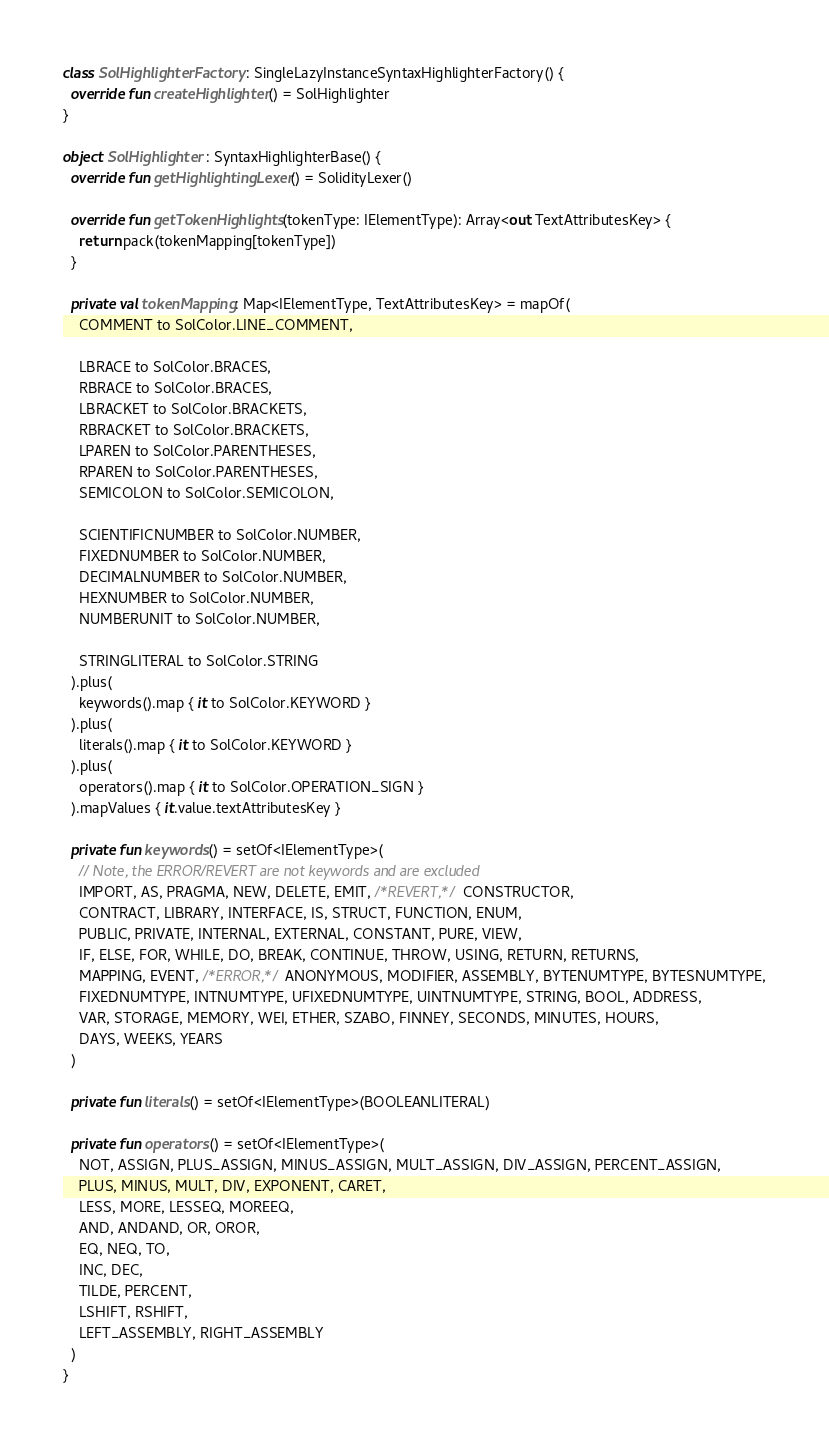Convert code to text. <code><loc_0><loc_0><loc_500><loc_500><_Kotlin_>
class SolHighlighterFactory : SingleLazyInstanceSyntaxHighlighterFactory() {
  override fun createHighlighter() = SolHighlighter
}

object SolHighlighter : SyntaxHighlighterBase() {
  override fun getHighlightingLexer() = SolidityLexer()

  override fun getTokenHighlights(tokenType: IElementType): Array<out TextAttributesKey> {
    return pack(tokenMapping[tokenType])
  }

  private val tokenMapping: Map<IElementType, TextAttributesKey> = mapOf(
    COMMENT to SolColor.LINE_COMMENT,

    LBRACE to SolColor.BRACES,
    RBRACE to SolColor.BRACES,
    LBRACKET to SolColor.BRACKETS,
    RBRACKET to SolColor.BRACKETS,
    LPAREN to SolColor.PARENTHESES,
    RPAREN to SolColor.PARENTHESES,
    SEMICOLON to SolColor.SEMICOLON,

    SCIENTIFICNUMBER to SolColor.NUMBER,
    FIXEDNUMBER to SolColor.NUMBER,
    DECIMALNUMBER to SolColor.NUMBER,
    HEXNUMBER to SolColor.NUMBER,
    NUMBERUNIT to SolColor.NUMBER,

    STRINGLITERAL to SolColor.STRING
  ).plus(
    keywords().map { it to SolColor.KEYWORD }
  ).plus(
    literals().map { it to SolColor.KEYWORD }
  ).plus(
    operators().map { it to SolColor.OPERATION_SIGN }
  ).mapValues { it.value.textAttributesKey }

  private fun keywords() = setOf<IElementType>(
    // Note, the ERROR/REVERT are not keywords and are excluded
    IMPORT, AS, PRAGMA, NEW, DELETE, EMIT, /*REVERT,*/ CONSTRUCTOR,
    CONTRACT, LIBRARY, INTERFACE, IS, STRUCT, FUNCTION, ENUM,
    PUBLIC, PRIVATE, INTERNAL, EXTERNAL, CONSTANT, PURE, VIEW,
    IF, ELSE, FOR, WHILE, DO, BREAK, CONTINUE, THROW, USING, RETURN, RETURNS,
    MAPPING, EVENT, /*ERROR,*/ ANONYMOUS, MODIFIER, ASSEMBLY, BYTENUMTYPE, BYTESNUMTYPE,
    FIXEDNUMTYPE, INTNUMTYPE, UFIXEDNUMTYPE, UINTNUMTYPE, STRING, BOOL, ADDRESS,
    VAR, STORAGE, MEMORY, WEI, ETHER, SZABO, FINNEY, SECONDS, MINUTES, HOURS,
    DAYS, WEEKS, YEARS
  )

  private fun literals() = setOf<IElementType>(BOOLEANLITERAL)

  private fun operators() = setOf<IElementType>(
    NOT, ASSIGN, PLUS_ASSIGN, MINUS_ASSIGN, MULT_ASSIGN, DIV_ASSIGN, PERCENT_ASSIGN,
    PLUS, MINUS, MULT, DIV, EXPONENT, CARET,
    LESS, MORE, LESSEQ, MOREEQ,
    AND, ANDAND, OR, OROR,
    EQ, NEQ, TO,
    INC, DEC,
    TILDE, PERCENT,
    LSHIFT, RSHIFT,
    LEFT_ASSEMBLY, RIGHT_ASSEMBLY
  )
}

</code> 